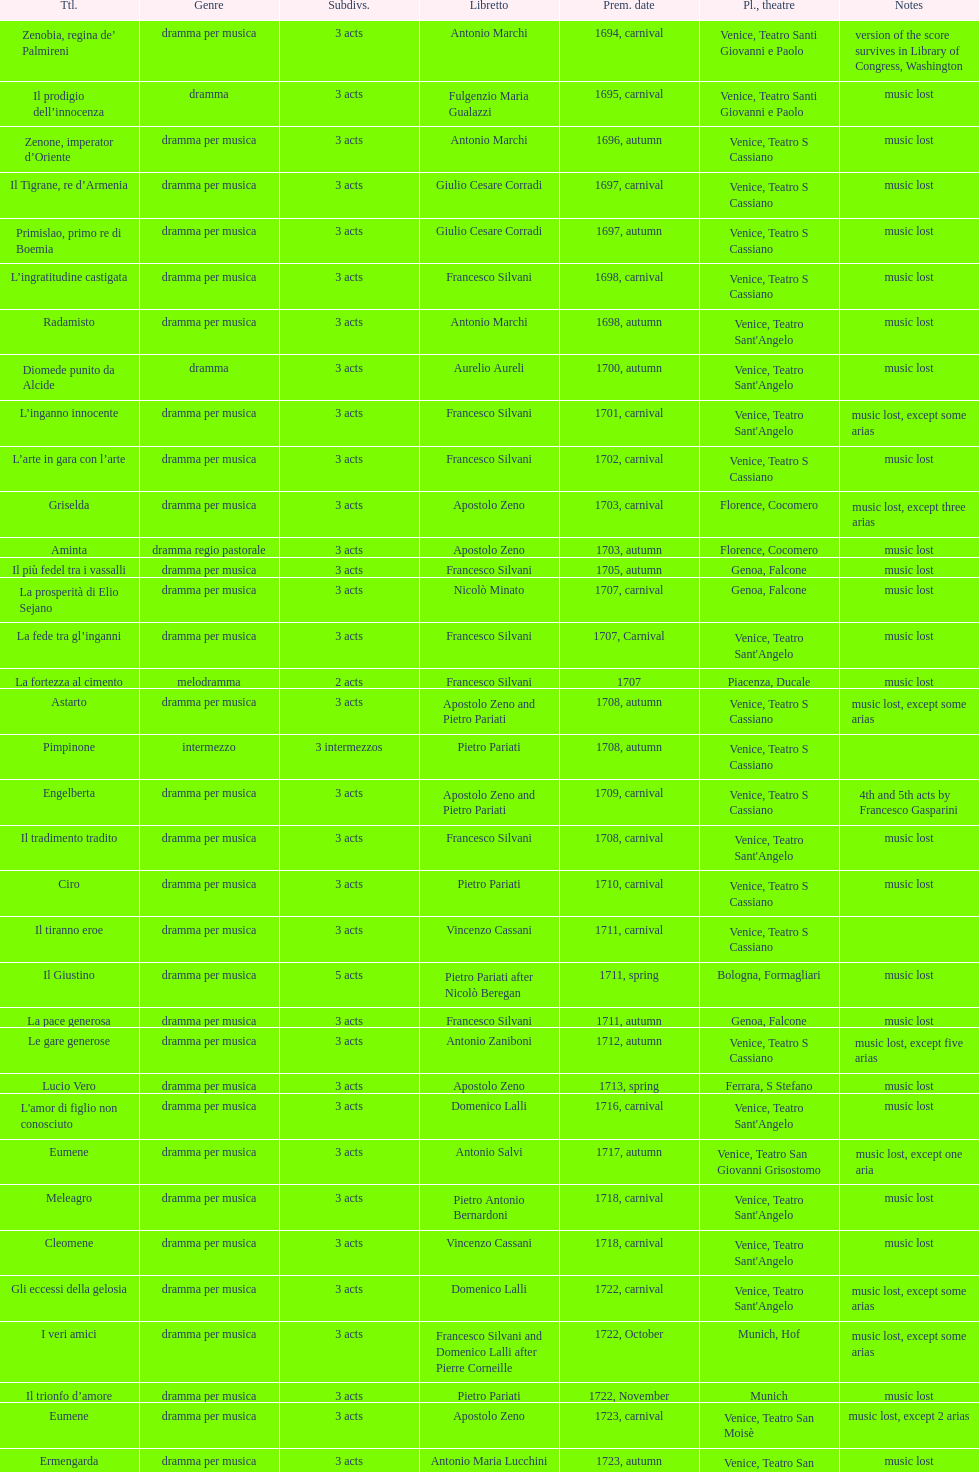Give me the full table as a dictionary. {'header': ['Ttl.', 'Genre', 'Sub\xaddivs.', 'Libretto', 'Prem. date', 'Pl., theatre', 'Notes'], 'rows': [['Zenobia, regina de’ Palmireni', 'dramma per musica', '3 acts', 'Antonio Marchi', '1694, carnival', 'Venice, Teatro Santi Giovanni e Paolo', 'version of the score survives in Library of Congress, Washington'], ['Il prodigio dell’innocenza', 'dramma', '3 acts', 'Fulgenzio Maria Gualazzi', '1695, carnival', 'Venice, Teatro Santi Giovanni e Paolo', 'music lost'], ['Zenone, imperator d’Oriente', 'dramma per musica', '3 acts', 'Antonio Marchi', '1696, autumn', 'Venice, Teatro S Cassiano', 'music lost'], ['Il Tigrane, re d’Armenia', 'dramma per musica', '3 acts', 'Giulio Cesare Corradi', '1697, carnival', 'Venice, Teatro S Cassiano', 'music lost'], ['Primislao, primo re di Boemia', 'dramma per musica', '3 acts', 'Giulio Cesare Corradi', '1697, autumn', 'Venice, Teatro S Cassiano', 'music lost'], ['L’ingratitudine castigata', 'dramma per musica', '3 acts', 'Francesco Silvani', '1698, carnival', 'Venice, Teatro S Cassiano', 'music lost'], ['Radamisto', 'dramma per musica', '3 acts', 'Antonio Marchi', '1698, autumn', "Venice, Teatro Sant'Angelo", 'music lost'], ['Diomede punito da Alcide', 'dramma', '3 acts', 'Aurelio Aureli', '1700, autumn', "Venice, Teatro Sant'Angelo", 'music lost'], ['L’inganno innocente', 'dramma per musica', '3 acts', 'Francesco Silvani', '1701, carnival', "Venice, Teatro Sant'Angelo", 'music lost, except some arias'], ['L’arte in gara con l’arte', 'dramma per musica', '3 acts', 'Francesco Silvani', '1702, carnival', 'Venice, Teatro S Cassiano', 'music lost'], ['Griselda', 'dramma per musica', '3 acts', 'Apostolo Zeno', '1703, carnival', 'Florence, Cocomero', 'music lost, except three arias'], ['Aminta', 'dramma regio pastorale', '3 acts', 'Apostolo Zeno', '1703, autumn', 'Florence, Cocomero', 'music lost'], ['Il più fedel tra i vassalli', 'dramma per musica', '3 acts', 'Francesco Silvani', '1705, autumn', 'Genoa, Falcone', 'music lost'], ['La prosperità di Elio Sejano', 'dramma per musica', '3 acts', 'Nicolò Minato', '1707, carnival', 'Genoa, Falcone', 'music lost'], ['La fede tra gl’inganni', 'dramma per musica', '3 acts', 'Francesco Silvani', '1707, Carnival', "Venice, Teatro Sant'Angelo", 'music lost'], ['La fortezza al cimento', 'melodramma', '2 acts', 'Francesco Silvani', '1707', 'Piacenza, Ducale', 'music lost'], ['Astarto', 'dramma per musica', '3 acts', 'Apostolo Zeno and Pietro Pariati', '1708, autumn', 'Venice, Teatro S Cassiano', 'music lost, except some arias'], ['Pimpinone', 'intermezzo', '3 intermezzos', 'Pietro Pariati', '1708, autumn', 'Venice, Teatro S Cassiano', ''], ['Engelberta', 'dramma per musica', '3 acts', 'Apostolo Zeno and Pietro Pariati', '1709, carnival', 'Venice, Teatro S Cassiano', '4th and 5th acts by Francesco Gasparini'], ['Il tradimento tradito', 'dramma per musica', '3 acts', 'Francesco Silvani', '1708, carnival', "Venice, Teatro Sant'Angelo", 'music lost'], ['Ciro', 'dramma per musica', '3 acts', 'Pietro Pariati', '1710, carnival', 'Venice, Teatro S Cassiano', 'music lost'], ['Il tiranno eroe', 'dramma per musica', '3 acts', 'Vincenzo Cassani', '1711, carnival', 'Venice, Teatro S Cassiano', ''], ['Il Giustino', 'dramma per musica', '5 acts', 'Pietro Pariati after Nicolò Beregan', '1711, spring', 'Bologna, Formagliari', 'music lost'], ['La pace generosa', 'dramma per musica', '3 acts', 'Francesco Silvani', '1711, autumn', 'Genoa, Falcone', 'music lost'], ['Le gare generose', 'dramma per musica', '3 acts', 'Antonio Zaniboni', '1712, autumn', 'Venice, Teatro S Cassiano', 'music lost, except five arias'], ['Lucio Vero', 'dramma per musica', '3 acts', 'Apostolo Zeno', '1713, spring', 'Ferrara, S Stefano', 'music lost'], ["L'amor di figlio non conosciuto", 'dramma per musica', '3 acts', 'Domenico Lalli', '1716, carnival', "Venice, Teatro Sant'Angelo", 'music lost'], ['Eumene', 'dramma per musica', '3 acts', 'Antonio Salvi', '1717, autumn', 'Venice, Teatro San Giovanni Grisostomo', 'music lost, except one aria'], ['Meleagro', 'dramma per musica', '3 acts', 'Pietro Antonio Bernardoni', '1718, carnival', "Venice, Teatro Sant'Angelo", 'music lost'], ['Cleomene', 'dramma per musica', '3 acts', 'Vincenzo Cassani', '1718, carnival', "Venice, Teatro Sant'Angelo", 'music lost'], ['Gli eccessi della gelosia', 'dramma per musica', '3 acts', 'Domenico Lalli', '1722, carnival', "Venice, Teatro Sant'Angelo", 'music lost, except some arias'], ['I veri amici', 'dramma per musica', '3 acts', 'Francesco Silvani and Domenico Lalli after Pierre Corneille', '1722, October', 'Munich, Hof', 'music lost, except some arias'], ['Il trionfo d’amore', 'dramma per musica', '3 acts', 'Pietro Pariati', '1722, November', 'Munich', 'music lost'], ['Eumene', 'dramma per musica', '3 acts', 'Apostolo Zeno', '1723, carnival', 'Venice, Teatro San Moisè', 'music lost, except 2 arias'], ['Ermengarda', 'dramma per musica', '3 acts', 'Antonio Maria Lucchini', '1723, autumn', 'Venice, Teatro San Moisè', 'music lost'], ['Antigono, tutore di Filippo, re di Macedonia', 'tragedia', '5 acts', 'Giovanni Piazzon', '1724, carnival', 'Venice, Teatro San Moisè', '5th act by Giovanni Porta, music lost'], ['Scipione nelle Spagne', 'dramma per musica', '3 acts', 'Apostolo Zeno', '1724, Ascension', 'Venice, Teatro San Samuele', 'music lost'], ['Laodice', 'dramma per musica', '3 acts', 'Angelo Schietti', '1724, autumn', 'Venice, Teatro San Moisè', 'music lost, except 2 arias'], ['Didone abbandonata', 'tragedia', '3 acts', 'Metastasio', '1725, carnival', 'Venice, Teatro S Cassiano', 'music lost'], ["L'impresario delle Isole Canarie", 'intermezzo', '2 acts', 'Metastasio', '1725, carnival', 'Venice, Teatro S Cassiano', 'music lost'], ['Alcina delusa da Ruggero', 'dramma per musica', '3 acts', 'Antonio Marchi', '1725, autumn', 'Venice, Teatro S Cassiano', 'music lost'], ['I rivali generosi', 'dramma per musica', '3 acts', 'Apostolo Zeno', '1725', 'Brescia, Nuovo', ''], ['La Statira', 'dramma per musica', '3 acts', 'Apostolo Zeno and Pietro Pariati', '1726, Carnival', 'Rome, Teatro Capranica', ''], ['Malsazio e Fiammetta', 'intermezzo', '', '', '1726, Carnival', 'Rome, Teatro Capranica', ''], ['Il trionfo di Armida', 'dramma per musica', '3 acts', 'Girolamo Colatelli after Torquato Tasso', '1726, autumn', 'Venice, Teatro San Moisè', 'music lost'], ['L’incostanza schernita', 'dramma comico-pastorale', '3 acts', 'Vincenzo Cassani', '1727, Ascension', 'Venice, Teatro San Samuele', 'music lost, except some arias'], ['Le due rivali in amore', 'dramma per musica', '3 acts', 'Aurelio Aureli', '1728, autumn', 'Venice, Teatro San Moisè', 'music lost'], ['Il Satrapone', 'intermezzo', '', 'Salvi', '1729', 'Parma, Omodeo', ''], ['Li stratagemmi amorosi', 'dramma per musica', '3 acts', 'F Passerini', '1730, carnival', 'Venice, Teatro San Moisè', 'music lost'], ['Elenia', 'dramma per musica', '3 acts', 'Luisa Bergalli', '1730, carnival', "Venice, Teatro Sant'Angelo", 'music lost'], ['Merope', 'dramma', '3 acts', 'Apostolo Zeno', '1731, autumn', 'Prague, Sporck Theater', 'mostly by Albinoni, music lost'], ['Il più infedel tra gli amanti', 'dramma per musica', '3 acts', 'Angelo Schietti', '1731, autumn', 'Treviso, Dolphin', 'music lost'], ['Ardelinda', 'dramma', '3 acts', 'Bartolomeo Vitturi', '1732, autumn', "Venice, Teatro Sant'Angelo", 'music lost, except five arias'], ['Candalide', 'dramma per musica', '3 acts', 'Bartolomeo Vitturi', '1734, carnival', "Venice, Teatro Sant'Angelo", 'music lost'], ['Artamene', 'dramma per musica', '3 acts', 'Bartolomeo Vitturi', '1741, carnival', "Venice, Teatro Sant'Angelo", 'music lost']]} Which opera has the most acts, la fortezza al cimento or astarto? Astarto. 